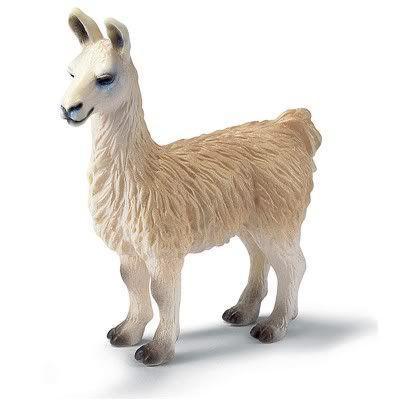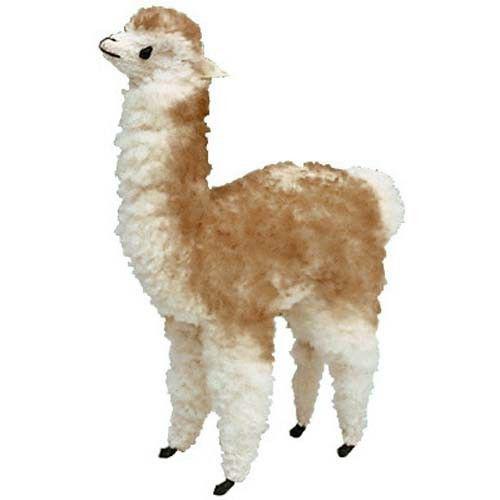The first image is the image on the left, the second image is the image on the right. Examine the images to the left and right. Is the description "There are exactly three llamas." accurate? Answer yes or no. No. The first image is the image on the left, the second image is the image on the right. Considering the images on both sides, is "Each image shows a single llama figure, which is standing in profile facing leftward." valid? Answer yes or no. Yes. 